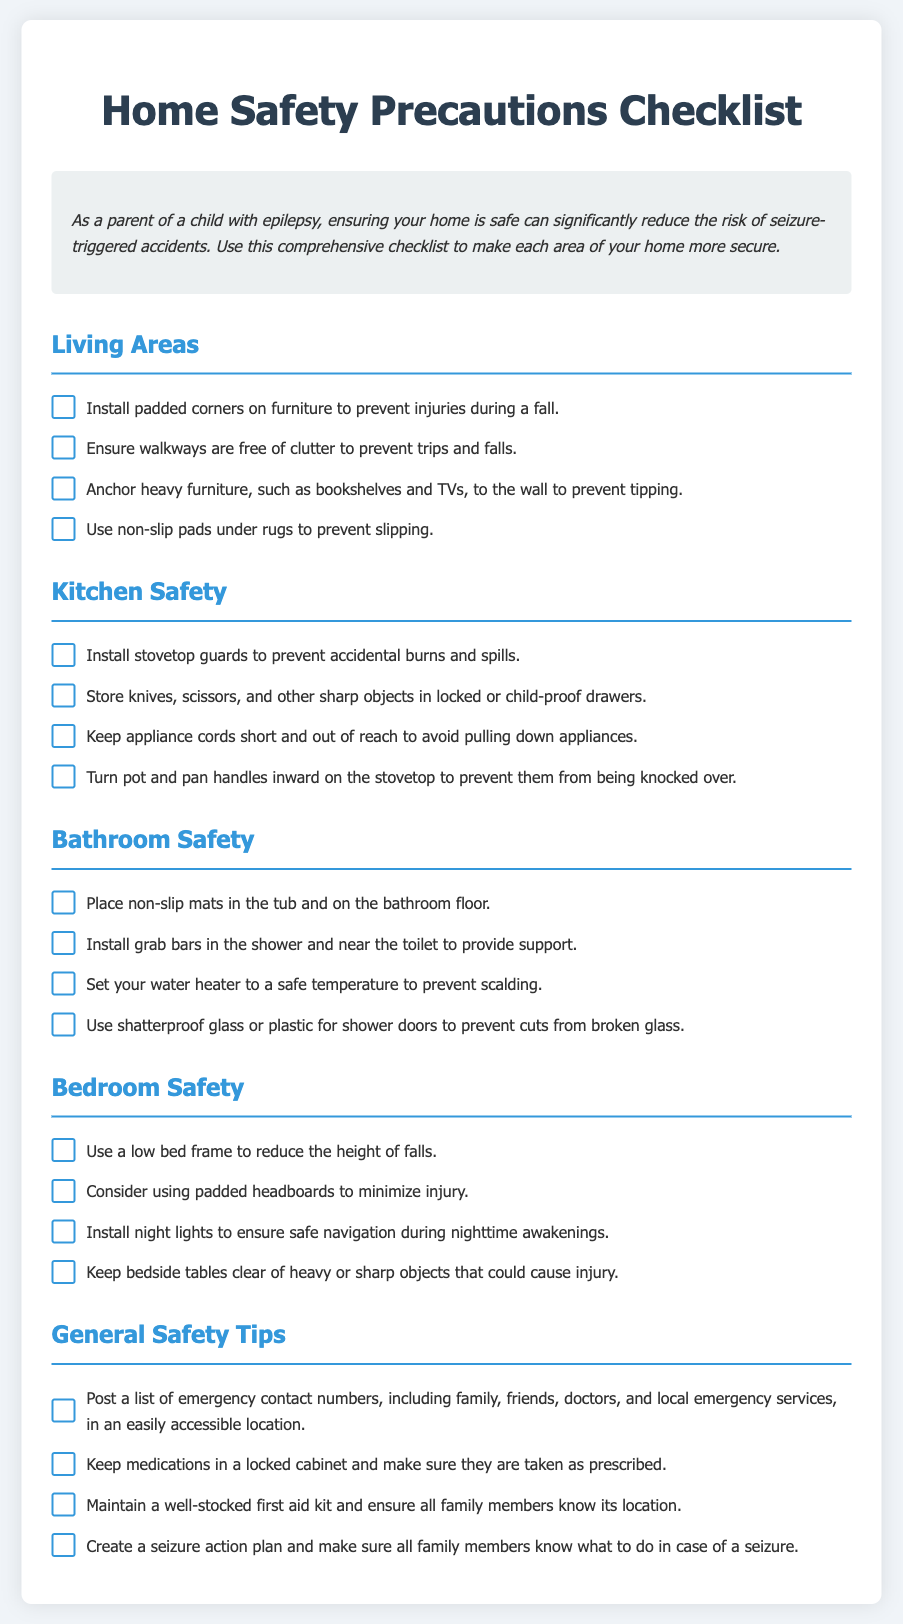what type of document is this? The document is a checklist detailing home safety precautions for epilepsy.
Answer: checklist how many living area safety precautions are listed? There are four safety precautions listed under living areas.
Answer: four what should be used in the tub for safety? Non-slip mats should be placed in the tub.
Answer: Non-slip mats what should you do with heavy furniture? Heavy furniture should be anchored to the wall.
Answer: anchored to the wall how many bathroom safety tips are mentioned? There are four safety tips mentioned for the bathroom.
Answer: four what is recommended to prevent slipping? Non-slip pads should be used under rugs.
Answer: Non-slip pads how should pot handles be positioned on the stovetop? Pot and pan handles should be turned inward.
Answer: turned inward what should be posted in an easily accessible location? A list of emergency contact numbers should be posted.
Answer: list of emergency contact numbers what type of glass should be used for shower doors? Shatterproof glass or plastic should be used.
Answer: Shatterproof glass or plastic 